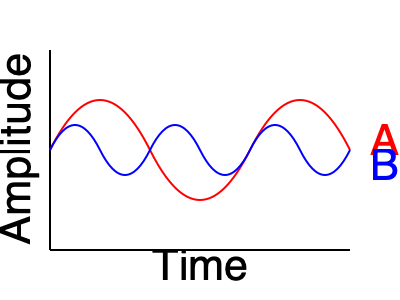In the graph above, two sound waves from different pop music genres are represented. Wave A (red) has a lower frequency and higher amplitude compared to Wave B (blue). Which of the following statements is true about the characteristics of these two waves?

A) Wave A represents a louder and higher-pitched sound than Wave B
B) Wave A represents a louder and lower-pitched sound than Wave B
C) Wave B represents a louder and higher-pitched sound than Wave A
D) Wave B represents a louder and lower-pitched sound than Wave A To answer this question, we need to understand the relationship between frequency, amplitude, pitch, and loudness in sound waves:

1. Frequency: The number of wave cycles per second, measured in Hertz (Hz).
   - Higher frequency = Higher pitch
   - Lower frequency = Lower pitch

2. Amplitude: The maximum displacement of a wave from its rest position.
   - Higher amplitude = Louder sound
   - Lower amplitude = Softer sound

Analyzing the waves in the graph:

3. Wave A (red):
   - Lower frequency (fewer wave cycles in the same time period)
   - Higher amplitude (larger vertical displacement)

4. Wave B (blue):
   - Higher frequency (more wave cycles in the same time period)
   - Lower amplitude (smaller vertical displacement)

5. Interpreting the characteristics:
   - Wave A has a lower pitch (due to lower frequency) and is louder (due to higher amplitude)
   - Wave B has a higher pitch (due to higher frequency) and is softer (due to lower amplitude)

6. Comparing the options:
   A) Incorrect: Wave A is louder but lower-pitched
   B) Correct: Wave A is louder and lower-pitched
   C) Incorrect: Wave B is softer and higher-pitched
   D) Incorrect: Wave B is softer but higher-pitched

Therefore, the correct answer is B: Wave A represents a louder and lower-pitched sound than Wave B.
Answer: B 